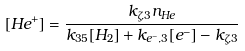Convert formula to latex. <formula><loc_0><loc_0><loc_500><loc_500>[ H e ^ { + } ] = \frac { k _ { \zeta , 3 } n _ { H e } } { k _ { 3 5 } [ H _ { 2 } ] + k _ { e ^ { - } , 3 } [ e ^ { - } ] - k _ { \zeta , 3 } }</formula> 